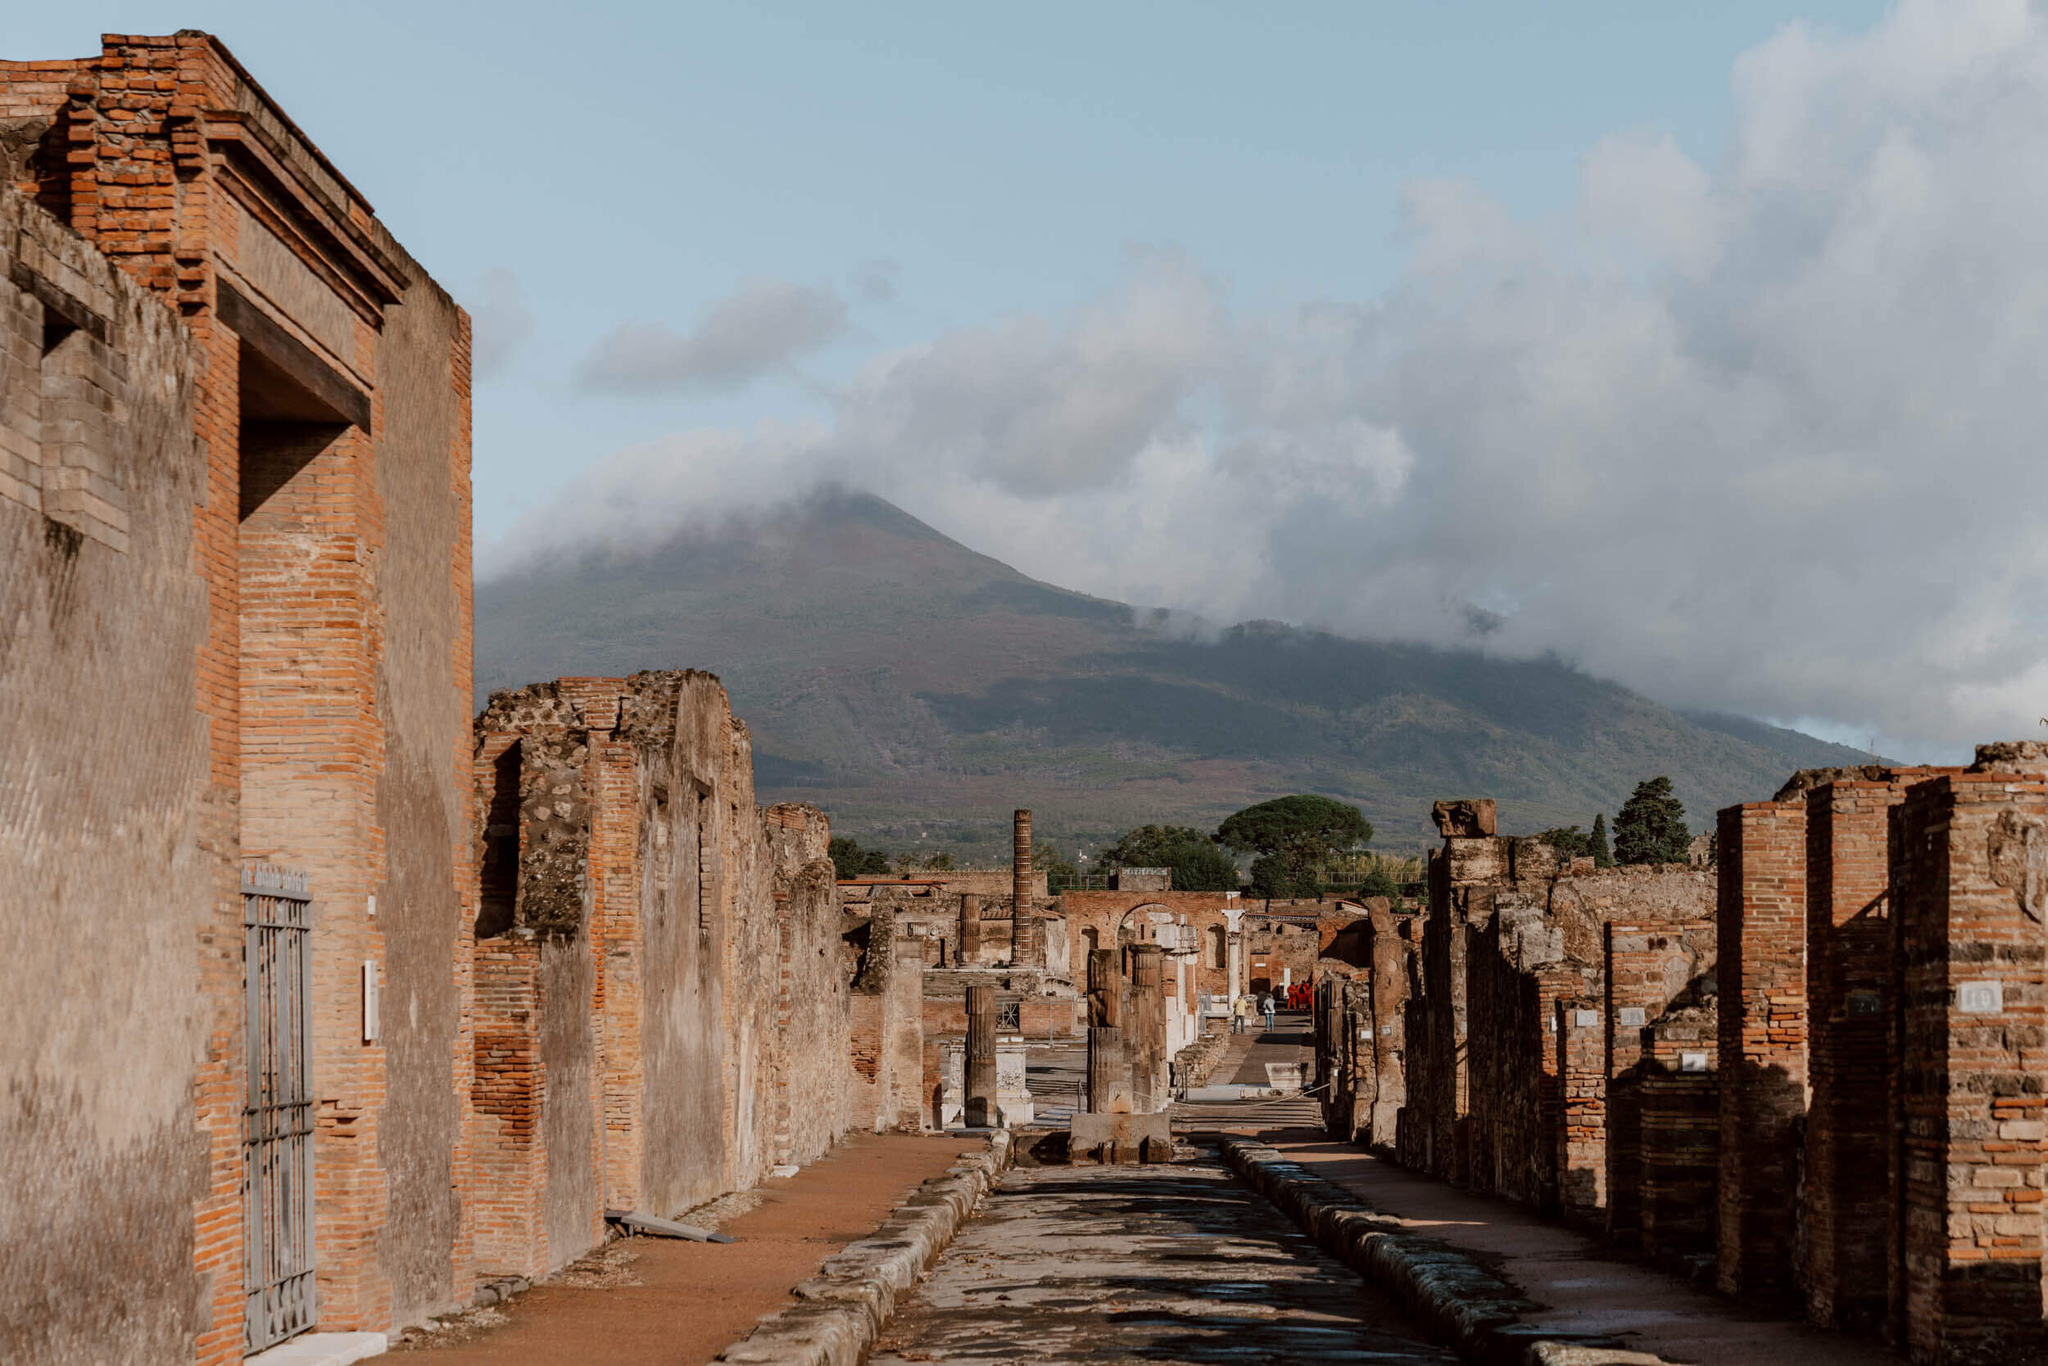Describe the daily life of a typical Pompeii resident based on the urban layout seen in the image. Pompeii was a bustling Roman city, and the urban layout as seen in the image reveals much about the daily life of its residents. The streets were meticulously planned and lined with shops, homes, and public buildings, reflecting a well-organized city. Early in the morning, residents would begin their day by visiting the markets to buy fresh produce, meats, and fish displayed by local vendors. The central street, likely used for commercial purposes, would be filled with the sounds of merchants calling out their wares, citizens haggling for the best prices, and the occasional chariot passing by.

Many households had running water, as suggested by the presence of public baths and fountains, indicating a relatively advanced state of public utilities. Social life in Pompeii was vibrant; the taverns and public houses along the streets provided gathering spots for people to socialize, enjoy meals, and engage in entertainment. The grandeur of the buildings suggests that public spectacles, such as theatrical performances and gladiatorial games, were an integral part of their culture, held in nearby arenas.

As the sun set, street lamps were lit, and the city would transition into a calmer mood. Families would retreat to their homes, perhaps enjoying modest feasts with wine in their atriums. The hustle and bustle of the day would give way to quieter evening conversations, with the silhouette of Mount Vesuvius ever present in the background, a silent guardian of the night. What lessons can modern urban planners learn from the ancient city layout of Pompeii? The ancient city layout of Pompeii offers several valuable lessons for modern urban planners:
1. **Efficient Use of Space**: The compact design of Pompeii’s streets and buildings demonstrates efficient use of available space, which is essential for accommodating a growing population within limited urban areas.
2. **Public Utilities and Sanitation**: The presence of public baths, fountains, and an advanced water distribution system highlights the importance of public utilities and sanitation in urban planning to ensure a healthy living environment.
3. **Mixed-Use Development**: Pompeii’s integration of residential, commercial, and public spaces within close proximity emphasizes the benefits of mixed-use development, promoting walkability and reducing reliance on transport.
4. **Community and Social Spaces**: The numerous public spaces, such as forums, theaters, and sports arenas, underscore the need for modern cities to include social and recreational areas that foster community interaction and cultural engagement.
5. **Resilience and Preparedness**: Pompeii’s tragic history with Mount Vesuvius serves as a reminder of the importance of building resilient cities that are prepared for natural disasters, incorporating effective evacuation routes and emergency response plans.

By studying the ancient city layout of Pompeii, modern urban planners can gain insights into creating sustainable, efficient, and resilient urban environments that serve the needs of their residents. 